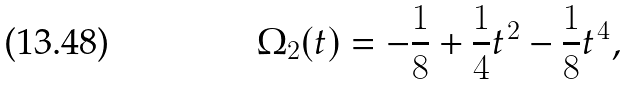<formula> <loc_0><loc_0><loc_500><loc_500>\Omega _ { 2 } ( t ) = - { \frac { 1 } { 8 } } + { \frac { 1 } { 4 } } t ^ { 2 } - { \frac { 1 } { 8 } } t ^ { 4 } ,</formula> 